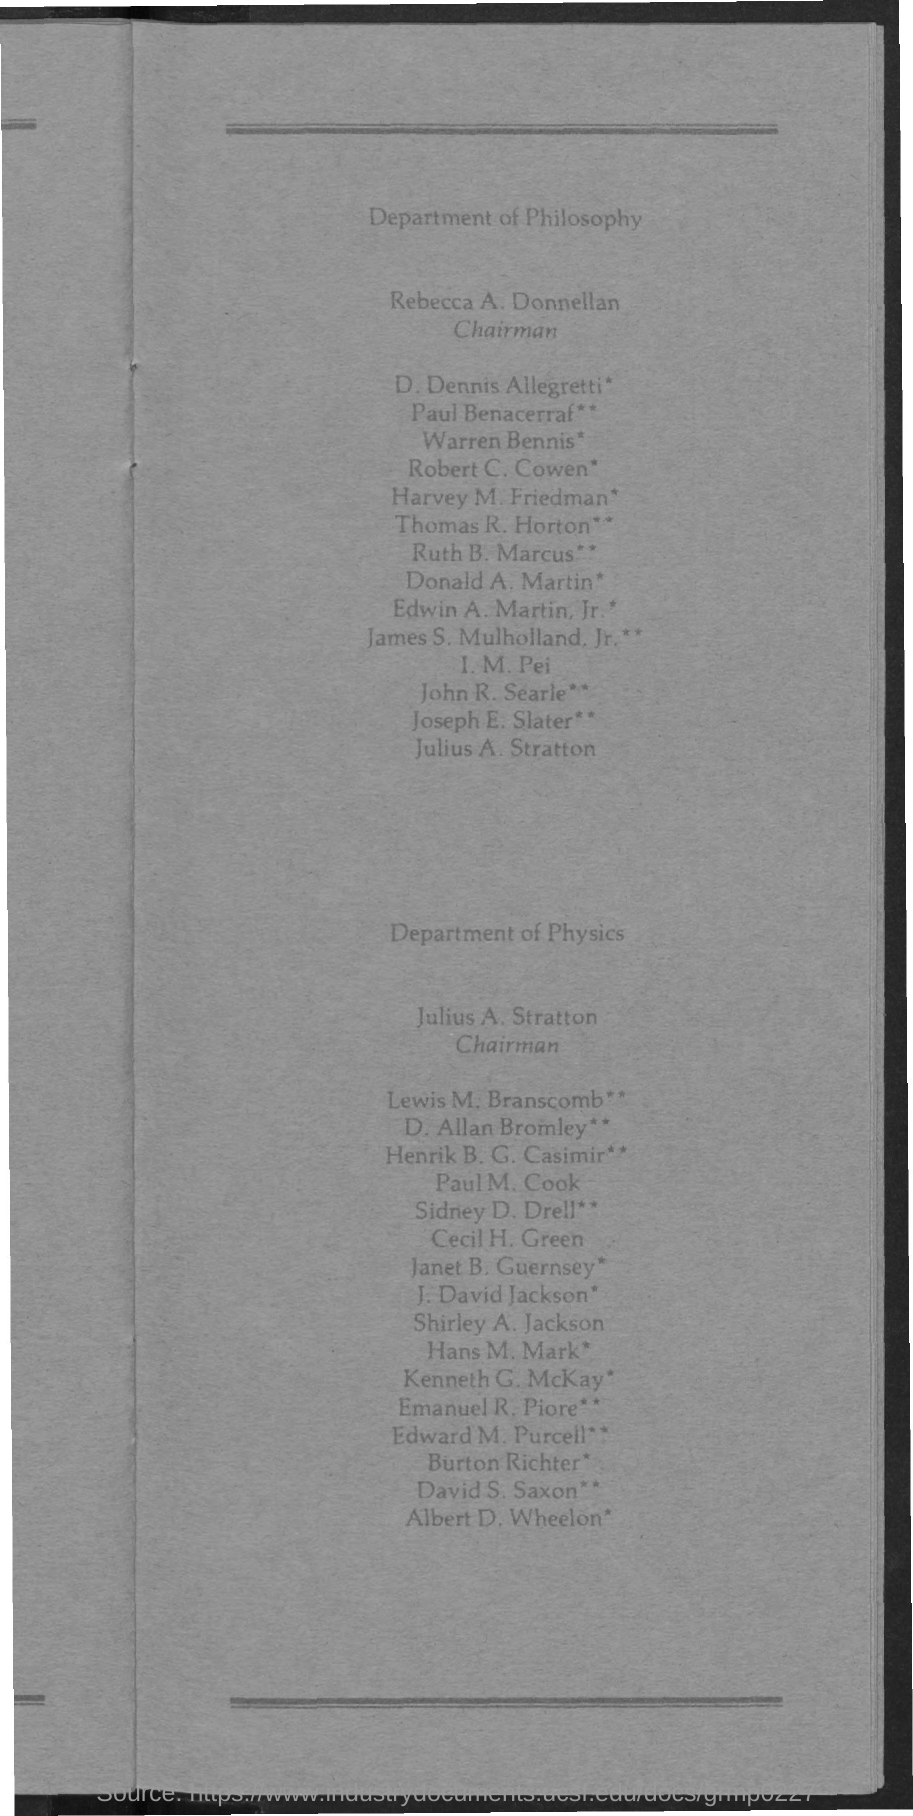Who is the Chairman for Department of Philosophy?
Your answer should be very brief. Rebecca A. Donnellan. Who is the Chairman for Department of Physics?
Make the answer very short. Julius A. Stratton. 